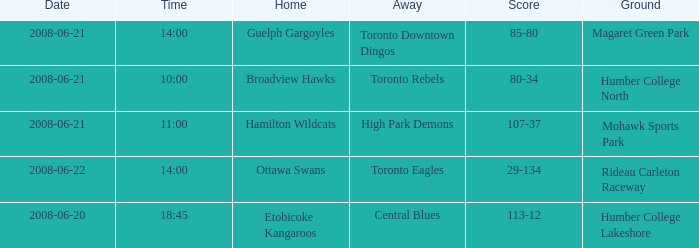What is the Away with a Ground that is humber college north? Toronto Rebels. 